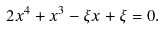Convert formula to latex. <formula><loc_0><loc_0><loc_500><loc_500>2 x ^ { 4 } + x ^ { 3 } - \xi x + \xi = 0 .</formula> 